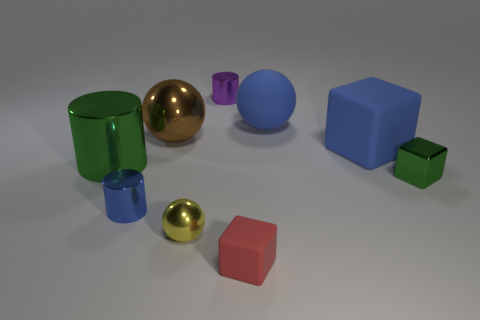Is the large rubber sphere the same color as the large rubber cube?
Ensure brevity in your answer.  Yes. What is the size of the yellow ball?
Provide a succinct answer. Small. There is a tiny cube in front of the tiny blue object; does it have the same color as the small cylinder that is on the left side of the purple object?
Ensure brevity in your answer.  No. How many other objects are the same material as the blue ball?
Your answer should be compact. 2. Are any yellow shiny things visible?
Your response must be concise. Yes. Is the big blue object that is in front of the big blue sphere made of the same material as the red thing?
Your answer should be very brief. Yes. What material is the brown thing that is the same shape as the yellow metallic thing?
Your answer should be compact. Metal. What is the material of the small block that is the same color as the large shiny cylinder?
Offer a terse response. Metal. Are there fewer brown spheres than tiny green balls?
Your answer should be very brief. No. There is a rubber cube on the right side of the small matte thing; is it the same color as the tiny rubber block?
Your answer should be very brief. No. 